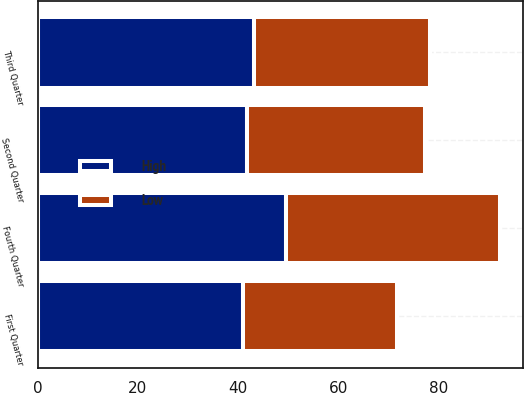Convert chart. <chart><loc_0><loc_0><loc_500><loc_500><stacked_bar_chart><ecel><fcel>First Quarter<fcel>Second Quarter<fcel>Third Quarter<fcel>Fourth Quarter<nl><fcel>High<fcel>40.92<fcel>41.83<fcel>43.11<fcel>49.52<nl><fcel>Low<fcel>30.65<fcel>35.4<fcel>35.2<fcel>42.6<nl></chart> 